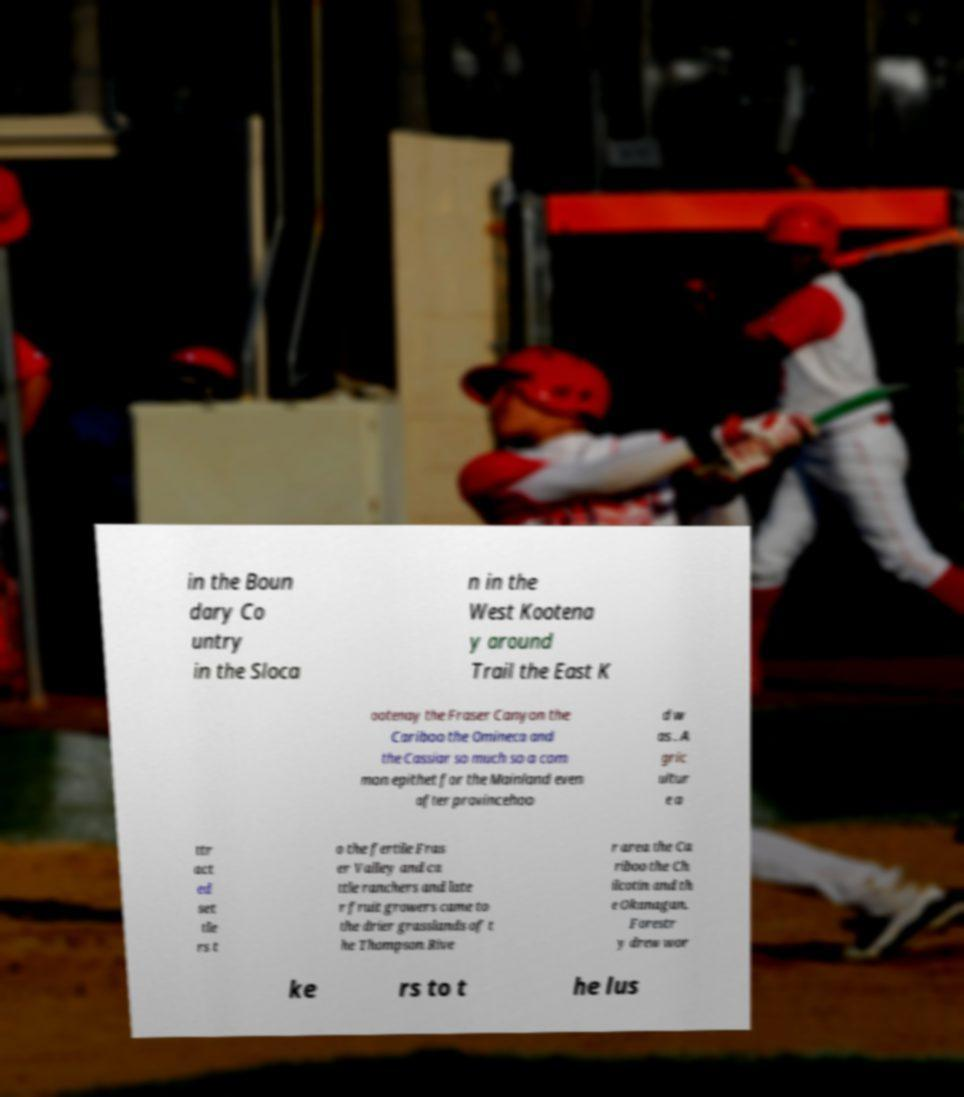Can you accurately transcribe the text from the provided image for me? in the Boun dary Co untry in the Sloca n in the West Kootena y around Trail the East K ootenay the Fraser Canyon the Cariboo the Omineca and the Cassiar so much so a com mon epithet for the Mainland even after provincehoo d w as . A gric ultur e a ttr act ed set tle rs t o the fertile Fras er Valley and ca ttle ranchers and late r fruit growers came to the drier grasslands of t he Thompson Rive r area the Ca riboo the Ch ilcotin and th e Okanagan. Forestr y drew wor ke rs to t he lus 